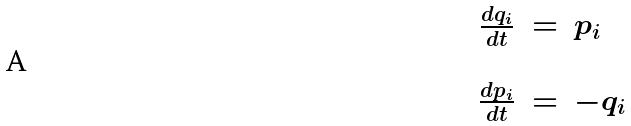<formula> <loc_0><loc_0><loc_500><loc_500>\begin{array} { r c l } \frac { d q _ { i } } { d t } & = & p _ { i } \\ \\ \frac { d p _ { i } } { d t } & = & - q _ { i } \end{array}</formula> 